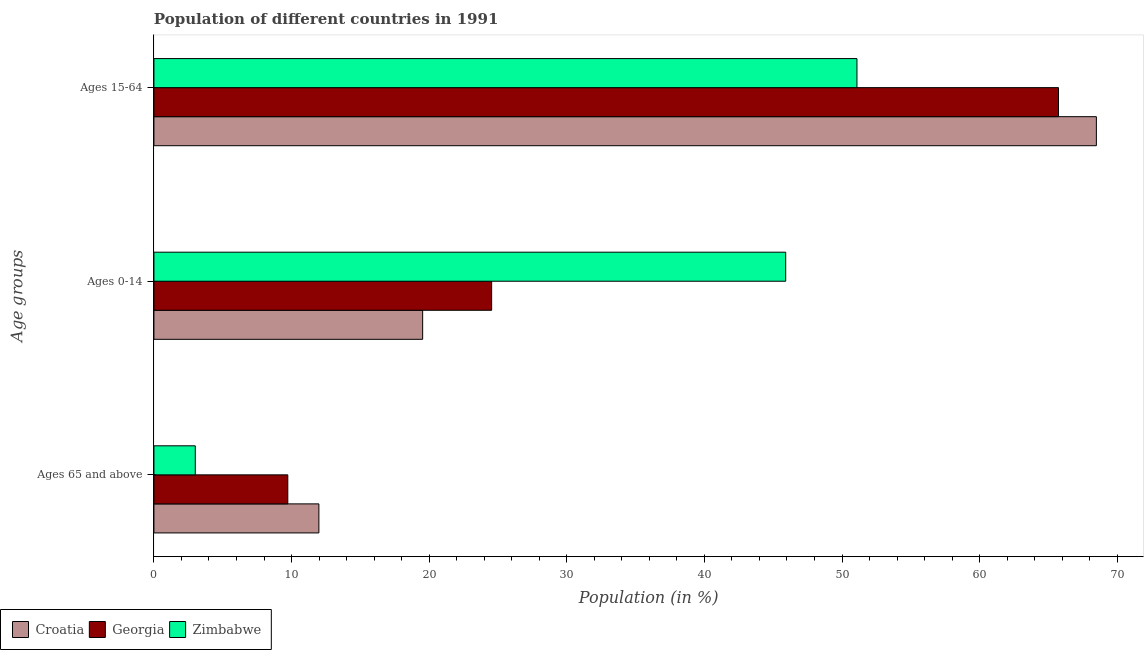How many different coloured bars are there?
Your response must be concise. 3. How many groups of bars are there?
Offer a terse response. 3. Are the number of bars per tick equal to the number of legend labels?
Make the answer very short. Yes. How many bars are there on the 2nd tick from the top?
Provide a succinct answer. 3. What is the label of the 3rd group of bars from the top?
Give a very brief answer. Ages 65 and above. What is the percentage of population within the age-group 15-64 in Zimbabwe?
Keep it short and to the point. 51.09. Across all countries, what is the maximum percentage of population within the age-group 15-64?
Ensure brevity in your answer.  68.48. Across all countries, what is the minimum percentage of population within the age-group of 65 and above?
Offer a terse response. 3.01. In which country was the percentage of population within the age-group 15-64 maximum?
Keep it short and to the point. Croatia. In which country was the percentage of population within the age-group of 65 and above minimum?
Your response must be concise. Zimbabwe. What is the total percentage of population within the age-group 0-14 in the graph?
Make the answer very short. 89.98. What is the difference between the percentage of population within the age-group 0-14 in Georgia and that in Croatia?
Your answer should be compact. 5.01. What is the difference between the percentage of population within the age-group of 65 and above in Zimbabwe and the percentage of population within the age-group 15-64 in Croatia?
Provide a succinct answer. -65.48. What is the average percentage of population within the age-group 0-14 per country?
Make the answer very short. 29.99. What is the difference between the percentage of population within the age-group 0-14 and percentage of population within the age-group of 65 and above in Croatia?
Keep it short and to the point. 7.54. In how many countries, is the percentage of population within the age-group of 65 and above greater than 30 %?
Keep it short and to the point. 0. What is the ratio of the percentage of population within the age-group 0-14 in Zimbabwe to that in Croatia?
Offer a terse response. 2.35. Is the percentage of population within the age-group of 65 and above in Georgia less than that in Croatia?
Offer a very short reply. Yes. What is the difference between the highest and the second highest percentage of population within the age-group 0-14?
Offer a very short reply. 21.37. What is the difference between the highest and the lowest percentage of population within the age-group of 65 and above?
Make the answer very short. 8.98. Is the sum of the percentage of population within the age-group 0-14 in Croatia and Zimbabwe greater than the maximum percentage of population within the age-group of 65 and above across all countries?
Offer a very short reply. Yes. What does the 1st bar from the top in Ages 65 and above represents?
Ensure brevity in your answer.  Zimbabwe. What does the 2nd bar from the bottom in Ages 15-64 represents?
Provide a succinct answer. Georgia. How many bars are there?
Provide a succinct answer. 9. What is the difference between two consecutive major ticks on the X-axis?
Give a very brief answer. 10. Does the graph contain grids?
Make the answer very short. No. How many legend labels are there?
Provide a short and direct response. 3. What is the title of the graph?
Provide a succinct answer. Population of different countries in 1991. What is the label or title of the X-axis?
Offer a very short reply. Population (in %). What is the label or title of the Y-axis?
Keep it short and to the point. Age groups. What is the Population (in %) of Croatia in Ages 65 and above?
Your answer should be compact. 11.99. What is the Population (in %) of Georgia in Ages 65 and above?
Give a very brief answer. 9.73. What is the Population (in %) in Zimbabwe in Ages 65 and above?
Provide a succinct answer. 3.01. What is the Population (in %) of Croatia in Ages 0-14?
Keep it short and to the point. 19.53. What is the Population (in %) in Georgia in Ages 0-14?
Provide a succinct answer. 24.54. What is the Population (in %) of Zimbabwe in Ages 0-14?
Provide a succinct answer. 45.91. What is the Population (in %) in Croatia in Ages 15-64?
Make the answer very short. 68.48. What is the Population (in %) in Georgia in Ages 15-64?
Provide a short and direct response. 65.73. What is the Population (in %) of Zimbabwe in Ages 15-64?
Offer a very short reply. 51.09. Across all Age groups, what is the maximum Population (in %) in Croatia?
Provide a succinct answer. 68.48. Across all Age groups, what is the maximum Population (in %) of Georgia?
Your answer should be compact. 65.73. Across all Age groups, what is the maximum Population (in %) of Zimbabwe?
Offer a terse response. 51.09. Across all Age groups, what is the minimum Population (in %) of Croatia?
Provide a short and direct response. 11.99. Across all Age groups, what is the minimum Population (in %) of Georgia?
Offer a terse response. 9.73. Across all Age groups, what is the minimum Population (in %) of Zimbabwe?
Give a very brief answer. 3.01. What is the total Population (in %) of Croatia in the graph?
Your answer should be very brief. 100. What is the difference between the Population (in %) in Croatia in Ages 65 and above and that in Ages 0-14?
Your answer should be compact. -7.54. What is the difference between the Population (in %) in Georgia in Ages 65 and above and that in Ages 0-14?
Make the answer very short. -14.81. What is the difference between the Population (in %) of Zimbabwe in Ages 65 and above and that in Ages 0-14?
Give a very brief answer. -42.9. What is the difference between the Population (in %) of Croatia in Ages 65 and above and that in Ages 15-64?
Your response must be concise. -56.5. What is the difference between the Population (in %) of Georgia in Ages 65 and above and that in Ages 15-64?
Your answer should be compact. -56. What is the difference between the Population (in %) in Zimbabwe in Ages 65 and above and that in Ages 15-64?
Provide a succinct answer. -48.08. What is the difference between the Population (in %) in Croatia in Ages 0-14 and that in Ages 15-64?
Make the answer very short. -48.96. What is the difference between the Population (in %) in Georgia in Ages 0-14 and that in Ages 15-64?
Ensure brevity in your answer.  -41.19. What is the difference between the Population (in %) in Zimbabwe in Ages 0-14 and that in Ages 15-64?
Offer a very short reply. -5.18. What is the difference between the Population (in %) of Croatia in Ages 65 and above and the Population (in %) of Georgia in Ages 0-14?
Keep it short and to the point. -12.55. What is the difference between the Population (in %) of Croatia in Ages 65 and above and the Population (in %) of Zimbabwe in Ages 0-14?
Offer a very short reply. -33.92. What is the difference between the Population (in %) in Georgia in Ages 65 and above and the Population (in %) in Zimbabwe in Ages 0-14?
Give a very brief answer. -36.18. What is the difference between the Population (in %) in Croatia in Ages 65 and above and the Population (in %) in Georgia in Ages 15-64?
Keep it short and to the point. -53.74. What is the difference between the Population (in %) of Croatia in Ages 65 and above and the Population (in %) of Zimbabwe in Ages 15-64?
Keep it short and to the point. -39.1. What is the difference between the Population (in %) of Georgia in Ages 65 and above and the Population (in %) of Zimbabwe in Ages 15-64?
Make the answer very short. -41.36. What is the difference between the Population (in %) in Croatia in Ages 0-14 and the Population (in %) in Georgia in Ages 15-64?
Ensure brevity in your answer.  -46.2. What is the difference between the Population (in %) of Croatia in Ages 0-14 and the Population (in %) of Zimbabwe in Ages 15-64?
Make the answer very short. -31.56. What is the difference between the Population (in %) of Georgia in Ages 0-14 and the Population (in %) of Zimbabwe in Ages 15-64?
Your response must be concise. -26.55. What is the average Population (in %) in Croatia per Age groups?
Provide a succinct answer. 33.33. What is the average Population (in %) in Georgia per Age groups?
Your answer should be compact. 33.33. What is the average Population (in %) in Zimbabwe per Age groups?
Offer a very short reply. 33.33. What is the difference between the Population (in %) in Croatia and Population (in %) in Georgia in Ages 65 and above?
Your answer should be compact. 2.26. What is the difference between the Population (in %) of Croatia and Population (in %) of Zimbabwe in Ages 65 and above?
Ensure brevity in your answer.  8.98. What is the difference between the Population (in %) of Georgia and Population (in %) of Zimbabwe in Ages 65 and above?
Provide a short and direct response. 6.72. What is the difference between the Population (in %) of Croatia and Population (in %) of Georgia in Ages 0-14?
Keep it short and to the point. -5.01. What is the difference between the Population (in %) of Croatia and Population (in %) of Zimbabwe in Ages 0-14?
Offer a very short reply. -26.38. What is the difference between the Population (in %) of Georgia and Population (in %) of Zimbabwe in Ages 0-14?
Your answer should be very brief. -21.37. What is the difference between the Population (in %) of Croatia and Population (in %) of Georgia in Ages 15-64?
Provide a succinct answer. 2.75. What is the difference between the Population (in %) of Croatia and Population (in %) of Zimbabwe in Ages 15-64?
Offer a terse response. 17.4. What is the difference between the Population (in %) in Georgia and Population (in %) in Zimbabwe in Ages 15-64?
Your answer should be very brief. 14.65. What is the ratio of the Population (in %) of Croatia in Ages 65 and above to that in Ages 0-14?
Your response must be concise. 0.61. What is the ratio of the Population (in %) in Georgia in Ages 65 and above to that in Ages 0-14?
Your response must be concise. 0.4. What is the ratio of the Population (in %) in Zimbabwe in Ages 65 and above to that in Ages 0-14?
Your response must be concise. 0.07. What is the ratio of the Population (in %) in Croatia in Ages 65 and above to that in Ages 15-64?
Your answer should be compact. 0.17. What is the ratio of the Population (in %) in Georgia in Ages 65 and above to that in Ages 15-64?
Keep it short and to the point. 0.15. What is the ratio of the Population (in %) of Zimbabwe in Ages 65 and above to that in Ages 15-64?
Offer a terse response. 0.06. What is the ratio of the Population (in %) of Croatia in Ages 0-14 to that in Ages 15-64?
Make the answer very short. 0.29. What is the ratio of the Population (in %) in Georgia in Ages 0-14 to that in Ages 15-64?
Offer a very short reply. 0.37. What is the ratio of the Population (in %) in Zimbabwe in Ages 0-14 to that in Ages 15-64?
Your answer should be compact. 0.9. What is the difference between the highest and the second highest Population (in %) in Croatia?
Offer a terse response. 48.96. What is the difference between the highest and the second highest Population (in %) in Georgia?
Offer a very short reply. 41.19. What is the difference between the highest and the second highest Population (in %) of Zimbabwe?
Offer a terse response. 5.18. What is the difference between the highest and the lowest Population (in %) of Croatia?
Provide a short and direct response. 56.5. What is the difference between the highest and the lowest Population (in %) of Georgia?
Your response must be concise. 56. What is the difference between the highest and the lowest Population (in %) in Zimbabwe?
Your answer should be very brief. 48.08. 